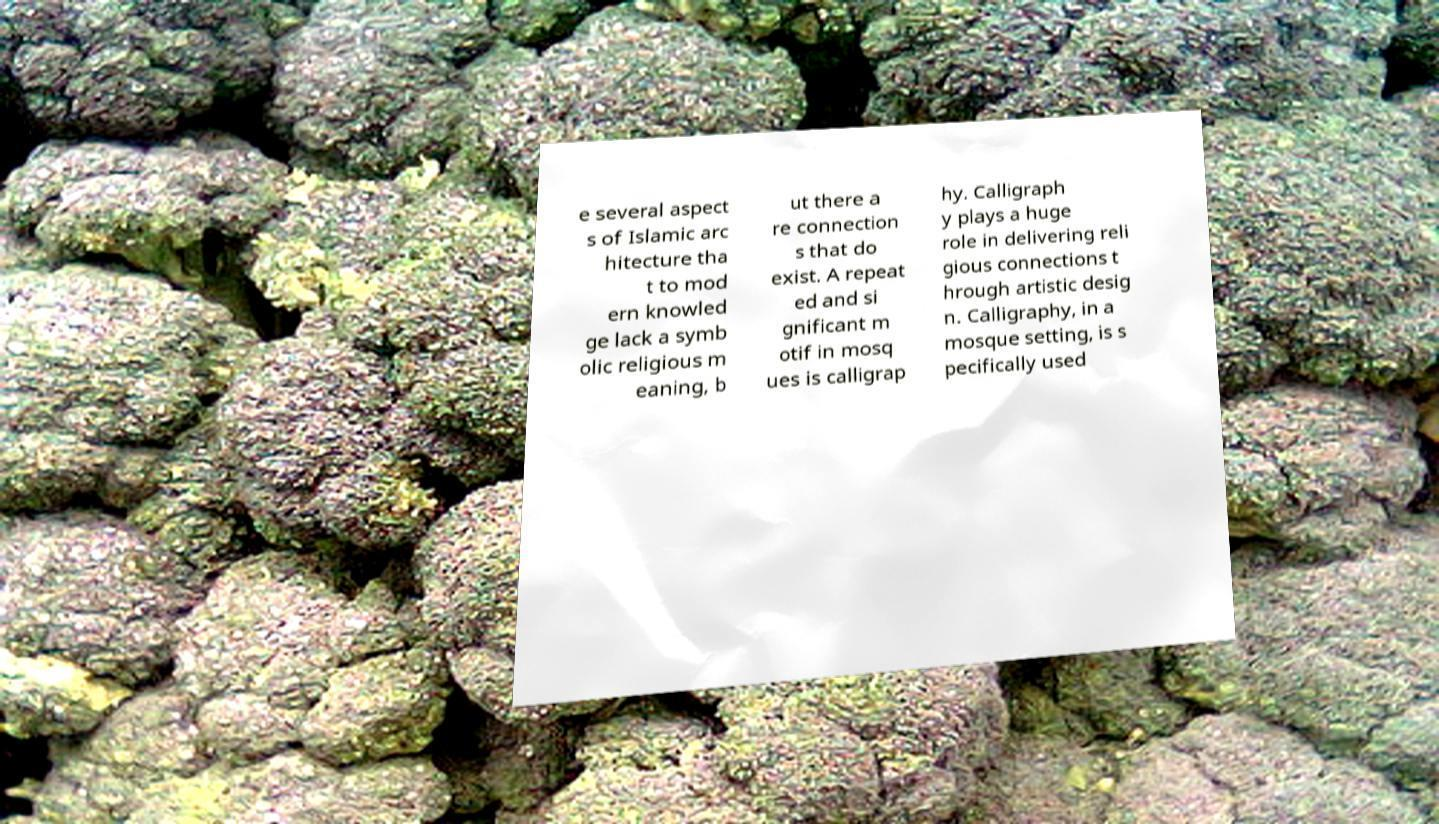Could you extract and type out the text from this image? e several aspect s of Islamic arc hitecture tha t to mod ern knowled ge lack a symb olic religious m eaning, b ut there a re connection s that do exist. A repeat ed and si gnificant m otif in mosq ues is calligrap hy. Calligraph y plays a huge role in delivering reli gious connections t hrough artistic desig n. Calligraphy, in a mosque setting, is s pecifically used 